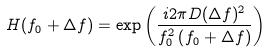<formula> <loc_0><loc_0><loc_500><loc_500>H ( f _ { 0 } + \Delta f ) = \exp { \left ( \frac { i 2 \pi D ( \Delta f ) ^ { 2 } } { f _ { 0 } ^ { 2 } \left ( f _ { 0 } + \Delta f \right ) } \right ) }</formula> 